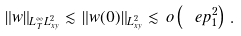Convert formula to latex. <formula><loc_0><loc_0><loc_500><loc_500>\| w \| _ { L ^ { \infty } _ { T } L ^ { 2 } _ { x y } } \lesssim \, \| w ( 0 ) \| _ { L ^ { 2 } _ { x y } } \lesssim \, o \left ( \ e p _ { 1 } ^ { 2 } \right ) \, .</formula> 